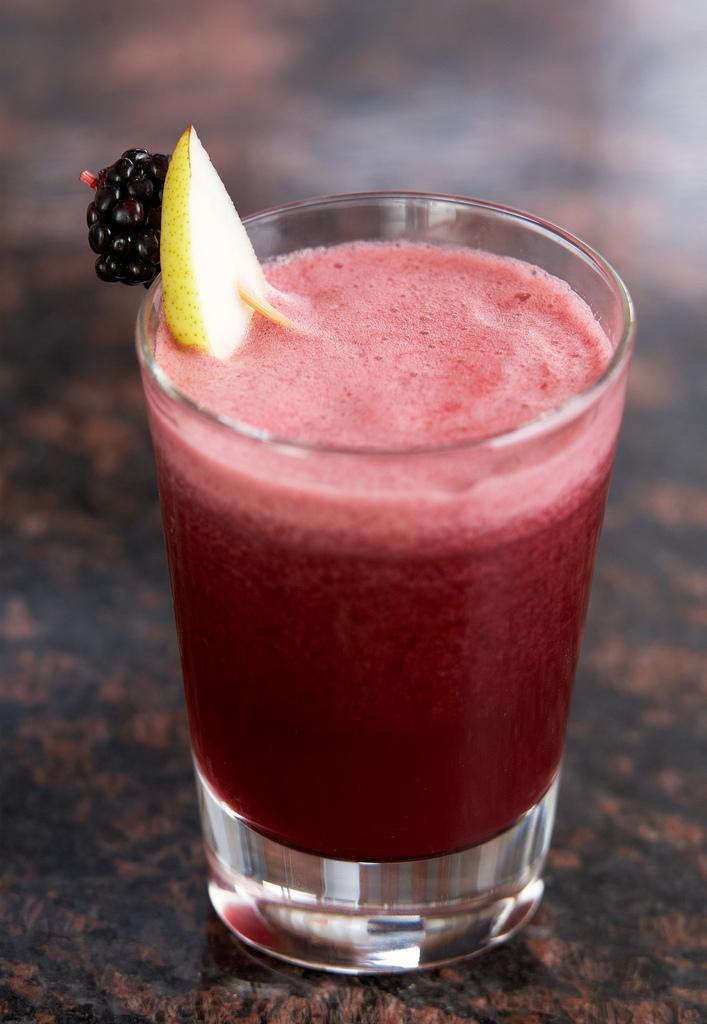Describe this image in one or two sentences. In this picture a juice is highlighted. The juice is in red color. It is presented in a glass with a an apple and a berry. 